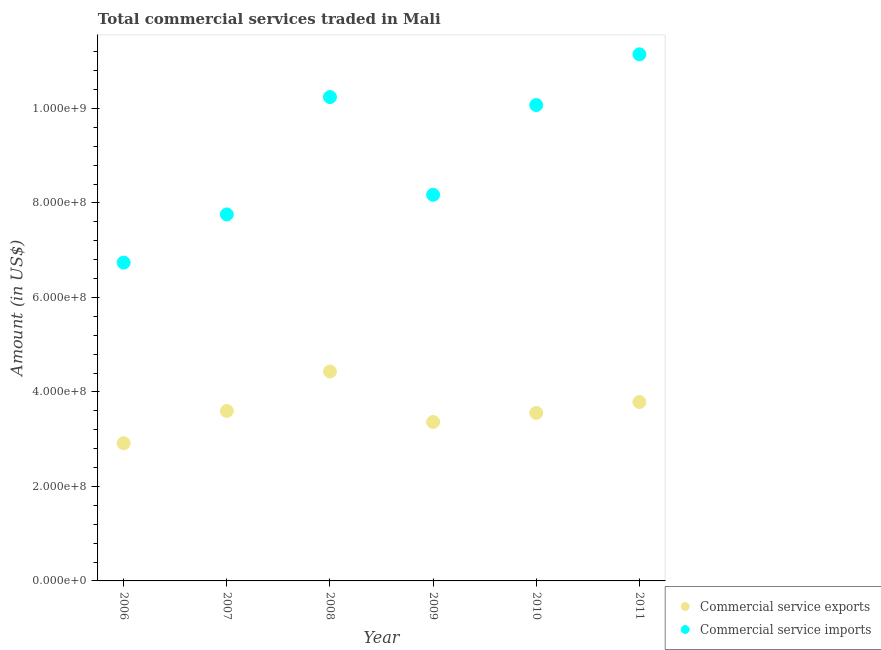How many different coloured dotlines are there?
Give a very brief answer. 2. Is the number of dotlines equal to the number of legend labels?
Offer a terse response. Yes. What is the amount of commercial service exports in 2010?
Provide a short and direct response. 3.56e+08. Across all years, what is the maximum amount of commercial service imports?
Offer a very short reply. 1.11e+09. Across all years, what is the minimum amount of commercial service exports?
Give a very brief answer. 2.91e+08. What is the total amount of commercial service exports in the graph?
Ensure brevity in your answer.  2.17e+09. What is the difference between the amount of commercial service imports in 2006 and that in 2008?
Your response must be concise. -3.50e+08. What is the difference between the amount of commercial service exports in 2011 and the amount of commercial service imports in 2006?
Keep it short and to the point. -2.95e+08. What is the average amount of commercial service exports per year?
Your answer should be compact. 3.61e+08. In the year 2011, what is the difference between the amount of commercial service exports and amount of commercial service imports?
Your answer should be compact. -7.36e+08. In how many years, is the amount of commercial service imports greater than 320000000 US$?
Make the answer very short. 6. What is the ratio of the amount of commercial service imports in 2007 to that in 2008?
Your response must be concise. 0.76. Is the difference between the amount of commercial service exports in 2006 and 2007 greater than the difference between the amount of commercial service imports in 2006 and 2007?
Keep it short and to the point. Yes. What is the difference between the highest and the second highest amount of commercial service imports?
Your answer should be very brief. 9.05e+07. What is the difference between the highest and the lowest amount of commercial service exports?
Your answer should be very brief. 1.52e+08. In how many years, is the amount of commercial service exports greater than the average amount of commercial service exports taken over all years?
Offer a terse response. 2. Is the amount of commercial service imports strictly greater than the amount of commercial service exports over the years?
Your response must be concise. Yes. Is the amount of commercial service imports strictly less than the amount of commercial service exports over the years?
Provide a short and direct response. No. How many dotlines are there?
Your response must be concise. 2. What is the difference between two consecutive major ticks on the Y-axis?
Your answer should be compact. 2.00e+08. Are the values on the major ticks of Y-axis written in scientific E-notation?
Keep it short and to the point. Yes. Does the graph contain grids?
Offer a very short reply. No. How many legend labels are there?
Make the answer very short. 2. What is the title of the graph?
Keep it short and to the point. Total commercial services traded in Mali. Does "Arms imports" appear as one of the legend labels in the graph?
Offer a terse response. No. What is the label or title of the X-axis?
Ensure brevity in your answer.  Year. What is the Amount (in US$) of Commercial service exports in 2006?
Your answer should be compact. 2.91e+08. What is the Amount (in US$) of Commercial service imports in 2006?
Ensure brevity in your answer.  6.74e+08. What is the Amount (in US$) in Commercial service exports in 2007?
Your answer should be very brief. 3.60e+08. What is the Amount (in US$) of Commercial service imports in 2007?
Offer a terse response. 7.76e+08. What is the Amount (in US$) in Commercial service exports in 2008?
Ensure brevity in your answer.  4.43e+08. What is the Amount (in US$) of Commercial service imports in 2008?
Ensure brevity in your answer.  1.02e+09. What is the Amount (in US$) of Commercial service exports in 2009?
Offer a terse response. 3.36e+08. What is the Amount (in US$) of Commercial service imports in 2009?
Give a very brief answer. 8.17e+08. What is the Amount (in US$) in Commercial service exports in 2010?
Offer a very short reply. 3.56e+08. What is the Amount (in US$) of Commercial service imports in 2010?
Provide a succinct answer. 1.01e+09. What is the Amount (in US$) in Commercial service exports in 2011?
Offer a terse response. 3.79e+08. What is the Amount (in US$) of Commercial service imports in 2011?
Provide a short and direct response. 1.11e+09. Across all years, what is the maximum Amount (in US$) of Commercial service exports?
Offer a terse response. 4.43e+08. Across all years, what is the maximum Amount (in US$) in Commercial service imports?
Ensure brevity in your answer.  1.11e+09. Across all years, what is the minimum Amount (in US$) in Commercial service exports?
Give a very brief answer. 2.91e+08. Across all years, what is the minimum Amount (in US$) in Commercial service imports?
Provide a succinct answer. 6.74e+08. What is the total Amount (in US$) of Commercial service exports in the graph?
Provide a short and direct response. 2.17e+09. What is the total Amount (in US$) of Commercial service imports in the graph?
Your response must be concise. 5.41e+09. What is the difference between the Amount (in US$) in Commercial service exports in 2006 and that in 2007?
Give a very brief answer. -6.82e+07. What is the difference between the Amount (in US$) of Commercial service imports in 2006 and that in 2007?
Your answer should be very brief. -1.02e+08. What is the difference between the Amount (in US$) of Commercial service exports in 2006 and that in 2008?
Give a very brief answer. -1.52e+08. What is the difference between the Amount (in US$) of Commercial service imports in 2006 and that in 2008?
Provide a short and direct response. -3.50e+08. What is the difference between the Amount (in US$) in Commercial service exports in 2006 and that in 2009?
Give a very brief answer. -4.49e+07. What is the difference between the Amount (in US$) in Commercial service imports in 2006 and that in 2009?
Make the answer very short. -1.44e+08. What is the difference between the Amount (in US$) of Commercial service exports in 2006 and that in 2010?
Your response must be concise. -6.42e+07. What is the difference between the Amount (in US$) in Commercial service imports in 2006 and that in 2010?
Give a very brief answer. -3.34e+08. What is the difference between the Amount (in US$) of Commercial service exports in 2006 and that in 2011?
Provide a short and direct response. -8.72e+07. What is the difference between the Amount (in US$) of Commercial service imports in 2006 and that in 2011?
Your answer should be compact. -4.41e+08. What is the difference between the Amount (in US$) in Commercial service exports in 2007 and that in 2008?
Give a very brief answer. -8.35e+07. What is the difference between the Amount (in US$) of Commercial service imports in 2007 and that in 2008?
Make the answer very short. -2.48e+08. What is the difference between the Amount (in US$) in Commercial service exports in 2007 and that in 2009?
Ensure brevity in your answer.  2.33e+07. What is the difference between the Amount (in US$) of Commercial service imports in 2007 and that in 2009?
Offer a terse response. -4.16e+07. What is the difference between the Amount (in US$) in Commercial service exports in 2007 and that in 2010?
Keep it short and to the point. 4.06e+06. What is the difference between the Amount (in US$) in Commercial service imports in 2007 and that in 2010?
Your response must be concise. -2.32e+08. What is the difference between the Amount (in US$) in Commercial service exports in 2007 and that in 2011?
Ensure brevity in your answer.  -1.90e+07. What is the difference between the Amount (in US$) in Commercial service imports in 2007 and that in 2011?
Provide a short and direct response. -3.39e+08. What is the difference between the Amount (in US$) in Commercial service exports in 2008 and that in 2009?
Make the answer very short. 1.07e+08. What is the difference between the Amount (in US$) in Commercial service imports in 2008 and that in 2009?
Offer a terse response. 2.07e+08. What is the difference between the Amount (in US$) in Commercial service exports in 2008 and that in 2010?
Offer a terse response. 8.76e+07. What is the difference between the Amount (in US$) in Commercial service imports in 2008 and that in 2010?
Provide a short and direct response. 1.69e+07. What is the difference between the Amount (in US$) in Commercial service exports in 2008 and that in 2011?
Give a very brief answer. 6.45e+07. What is the difference between the Amount (in US$) of Commercial service imports in 2008 and that in 2011?
Your response must be concise. -9.05e+07. What is the difference between the Amount (in US$) in Commercial service exports in 2009 and that in 2010?
Offer a terse response. -1.92e+07. What is the difference between the Amount (in US$) of Commercial service imports in 2009 and that in 2010?
Give a very brief answer. -1.90e+08. What is the difference between the Amount (in US$) of Commercial service exports in 2009 and that in 2011?
Ensure brevity in your answer.  -4.23e+07. What is the difference between the Amount (in US$) in Commercial service imports in 2009 and that in 2011?
Your answer should be very brief. -2.97e+08. What is the difference between the Amount (in US$) of Commercial service exports in 2010 and that in 2011?
Provide a succinct answer. -2.30e+07. What is the difference between the Amount (in US$) of Commercial service imports in 2010 and that in 2011?
Provide a succinct answer. -1.07e+08. What is the difference between the Amount (in US$) of Commercial service exports in 2006 and the Amount (in US$) of Commercial service imports in 2007?
Your answer should be compact. -4.84e+08. What is the difference between the Amount (in US$) in Commercial service exports in 2006 and the Amount (in US$) in Commercial service imports in 2008?
Your answer should be compact. -7.33e+08. What is the difference between the Amount (in US$) in Commercial service exports in 2006 and the Amount (in US$) in Commercial service imports in 2009?
Ensure brevity in your answer.  -5.26e+08. What is the difference between the Amount (in US$) of Commercial service exports in 2006 and the Amount (in US$) of Commercial service imports in 2010?
Your response must be concise. -7.16e+08. What is the difference between the Amount (in US$) in Commercial service exports in 2006 and the Amount (in US$) in Commercial service imports in 2011?
Your answer should be very brief. -8.23e+08. What is the difference between the Amount (in US$) in Commercial service exports in 2007 and the Amount (in US$) in Commercial service imports in 2008?
Your answer should be compact. -6.64e+08. What is the difference between the Amount (in US$) in Commercial service exports in 2007 and the Amount (in US$) in Commercial service imports in 2009?
Ensure brevity in your answer.  -4.58e+08. What is the difference between the Amount (in US$) of Commercial service exports in 2007 and the Amount (in US$) of Commercial service imports in 2010?
Give a very brief answer. -6.48e+08. What is the difference between the Amount (in US$) in Commercial service exports in 2007 and the Amount (in US$) in Commercial service imports in 2011?
Provide a succinct answer. -7.55e+08. What is the difference between the Amount (in US$) in Commercial service exports in 2008 and the Amount (in US$) in Commercial service imports in 2009?
Provide a succinct answer. -3.74e+08. What is the difference between the Amount (in US$) of Commercial service exports in 2008 and the Amount (in US$) of Commercial service imports in 2010?
Your answer should be compact. -5.64e+08. What is the difference between the Amount (in US$) in Commercial service exports in 2008 and the Amount (in US$) in Commercial service imports in 2011?
Offer a very short reply. -6.71e+08. What is the difference between the Amount (in US$) of Commercial service exports in 2009 and the Amount (in US$) of Commercial service imports in 2010?
Offer a very short reply. -6.71e+08. What is the difference between the Amount (in US$) in Commercial service exports in 2009 and the Amount (in US$) in Commercial service imports in 2011?
Provide a succinct answer. -7.78e+08. What is the difference between the Amount (in US$) in Commercial service exports in 2010 and the Amount (in US$) in Commercial service imports in 2011?
Ensure brevity in your answer.  -7.59e+08. What is the average Amount (in US$) of Commercial service exports per year?
Provide a short and direct response. 3.61e+08. What is the average Amount (in US$) of Commercial service imports per year?
Provide a succinct answer. 9.02e+08. In the year 2006, what is the difference between the Amount (in US$) of Commercial service exports and Amount (in US$) of Commercial service imports?
Your response must be concise. -3.82e+08. In the year 2007, what is the difference between the Amount (in US$) in Commercial service exports and Amount (in US$) in Commercial service imports?
Provide a succinct answer. -4.16e+08. In the year 2008, what is the difference between the Amount (in US$) of Commercial service exports and Amount (in US$) of Commercial service imports?
Your response must be concise. -5.81e+08. In the year 2009, what is the difference between the Amount (in US$) of Commercial service exports and Amount (in US$) of Commercial service imports?
Offer a terse response. -4.81e+08. In the year 2010, what is the difference between the Amount (in US$) in Commercial service exports and Amount (in US$) in Commercial service imports?
Provide a short and direct response. -6.52e+08. In the year 2011, what is the difference between the Amount (in US$) in Commercial service exports and Amount (in US$) in Commercial service imports?
Offer a terse response. -7.36e+08. What is the ratio of the Amount (in US$) of Commercial service exports in 2006 to that in 2007?
Provide a short and direct response. 0.81. What is the ratio of the Amount (in US$) in Commercial service imports in 2006 to that in 2007?
Your answer should be very brief. 0.87. What is the ratio of the Amount (in US$) of Commercial service exports in 2006 to that in 2008?
Provide a succinct answer. 0.66. What is the ratio of the Amount (in US$) in Commercial service imports in 2006 to that in 2008?
Give a very brief answer. 0.66. What is the ratio of the Amount (in US$) of Commercial service exports in 2006 to that in 2009?
Offer a very short reply. 0.87. What is the ratio of the Amount (in US$) in Commercial service imports in 2006 to that in 2009?
Ensure brevity in your answer.  0.82. What is the ratio of the Amount (in US$) of Commercial service exports in 2006 to that in 2010?
Give a very brief answer. 0.82. What is the ratio of the Amount (in US$) of Commercial service imports in 2006 to that in 2010?
Provide a short and direct response. 0.67. What is the ratio of the Amount (in US$) of Commercial service exports in 2006 to that in 2011?
Provide a short and direct response. 0.77. What is the ratio of the Amount (in US$) of Commercial service imports in 2006 to that in 2011?
Provide a succinct answer. 0.6. What is the ratio of the Amount (in US$) of Commercial service exports in 2007 to that in 2008?
Ensure brevity in your answer.  0.81. What is the ratio of the Amount (in US$) of Commercial service imports in 2007 to that in 2008?
Your answer should be very brief. 0.76. What is the ratio of the Amount (in US$) in Commercial service exports in 2007 to that in 2009?
Offer a very short reply. 1.07. What is the ratio of the Amount (in US$) of Commercial service imports in 2007 to that in 2009?
Your response must be concise. 0.95. What is the ratio of the Amount (in US$) of Commercial service exports in 2007 to that in 2010?
Keep it short and to the point. 1.01. What is the ratio of the Amount (in US$) of Commercial service imports in 2007 to that in 2010?
Your answer should be compact. 0.77. What is the ratio of the Amount (in US$) in Commercial service exports in 2007 to that in 2011?
Provide a short and direct response. 0.95. What is the ratio of the Amount (in US$) in Commercial service imports in 2007 to that in 2011?
Ensure brevity in your answer.  0.7. What is the ratio of the Amount (in US$) in Commercial service exports in 2008 to that in 2009?
Your response must be concise. 1.32. What is the ratio of the Amount (in US$) of Commercial service imports in 2008 to that in 2009?
Your response must be concise. 1.25. What is the ratio of the Amount (in US$) of Commercial service exports in 2008 to that in 2010?
Offer a terse response. 1.25. What is the ratio of the Amount (in US$) in Commercial service imports in 2008 to that in 2010?
Your answer should be compact. 1.02. What is the ratio of the Amount (in US$) of Commercial service exports in 2008 to that in 2011?
Provide a short and direct response. 1.17. What is the ratio of the Amount (in US$) in Commercial service imports in 2008 to that in 2011?
Ensure brevity in your answer.  0.92. What is the ratio of the Amount (in US$) in Commercial service exports in 2009 to that in 2010?
Your answer should be very brief. 0.95. What is the ratio of the Amount (in US$) in Commercial service imports in 2009 to that in 2010?
Offer a terse response. 0.81. What is the ratio of the Amount (in US$) in Commercial service exports in 2009 to that in 2011?
Your response must be concise. 0.89. What is the ratio of the Amount (in US$) in Commercial service imports in 2009 to that in 2011?
Offer a terse response. 0.73. What is the ratio of the Amount (in US$) in Commercial service exports in 2010 to that in 2011?
Provide a short and direct response. 0.94. What is the ratio of the Amount (in US$) in Commercial service imports in 2010 to that in 2011?
Provide a short and direct response. 0.9. What is the difference between the highest and the second highest Amount (in US$) of Commercial service exports?
Give a very brief answer. 6.45e+07. What is the difference between the highest and the second highest Amount (in US$) of Commercial service imports?
Provide a succinct answer. 9.05e+07. What is the difference between the highest and the lowest Amount (in US$) in Commercial service exports?
Provide a short and direct response. 1.52e+08. What is the difference between the highest and the lowest Amount (in US$) of Commercial service imports?
Your answer should be very brief. 4.41e+08. 